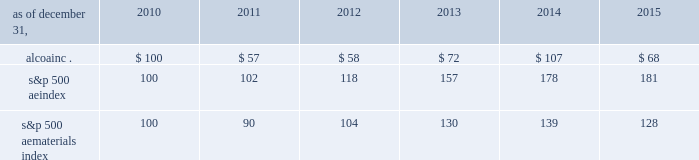Stock performance graph the following graph compares the most recent five-year performance of alcoa 2019s common stock with ( 1 ) the standard & poor 2019s 500 ae index and ( 2 ) the standard & poor 2019s 500 ae materials index , a group of 27 companies categorized by standard & poor 2019s as active in the 201cmaterials 201d market sector .
Such information shall not be deemed to be 201cfiled . 201d five-year cumulative total return based upon an initial investment of $ 100 on december 31 , 2010 with dividends reinvested alcoa inc .
S&p 500 ae index s&p 500 ae materials index dec-'10 dec-'11 dec-'12 dec-'14 dec-'15dec-'13 .
S&p 500 ae index 100 102 118 157 178 181 s&p 500 ae materials index 100 90 104 130 139 128 copyright a9 2016 standard & poor 2019s , a division of the mcgraw-hill companies inc .
All rights reserved .
Source : research data group , inc .
( www.researchdatagroup.com/s&p.htm ) .
What is the estimated annualized return for the initial $ 100 investment in the s&p 500 aeindex? 
Rationale: it is the total percentual return turned into the annual return , considering the initial $ 100 investment in the s&p 500 aeindex .
Computations: (((181 - 100) ** ((1 / 5) - 1)) - 1)
Answer: -0.97027. 